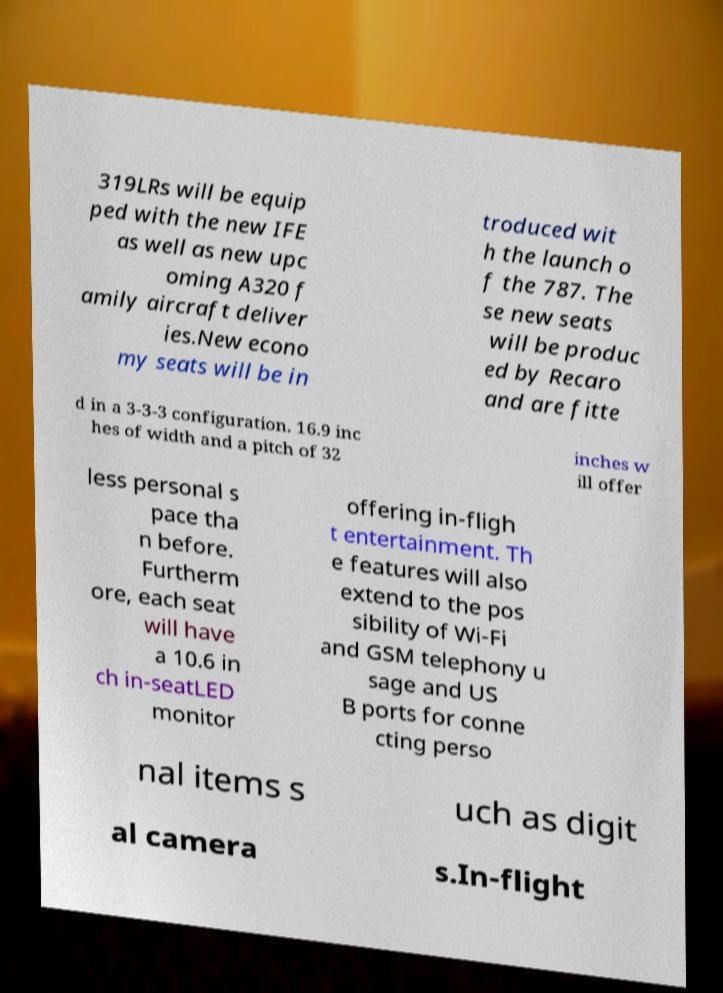For documentation purposes, I need the text within this image transcribed. Could you provide that? 319LRs will be equip ped with the new IFE as well as new upc oming A320 f amily aircraft deliver ies.New econo my seats will be in troduced wit h the launch o f the 787. The se new seats will be produc ed by Recaro and are fitte d in a 3-3-3 configuration. 16.9 inc hes of width and a pitch of 32 inches w ill offer less personal s pace tha n before. Furtherm ore, each seat will have a 10.6 in ch in-seatLED monitor offering in-fligh t entertainment. Th e features will also extend to the pos sibility of Wi-Fi and GSM telephony u sage and US B ports for conne cting perso nal items s uch as digit al camera s.In-flight 